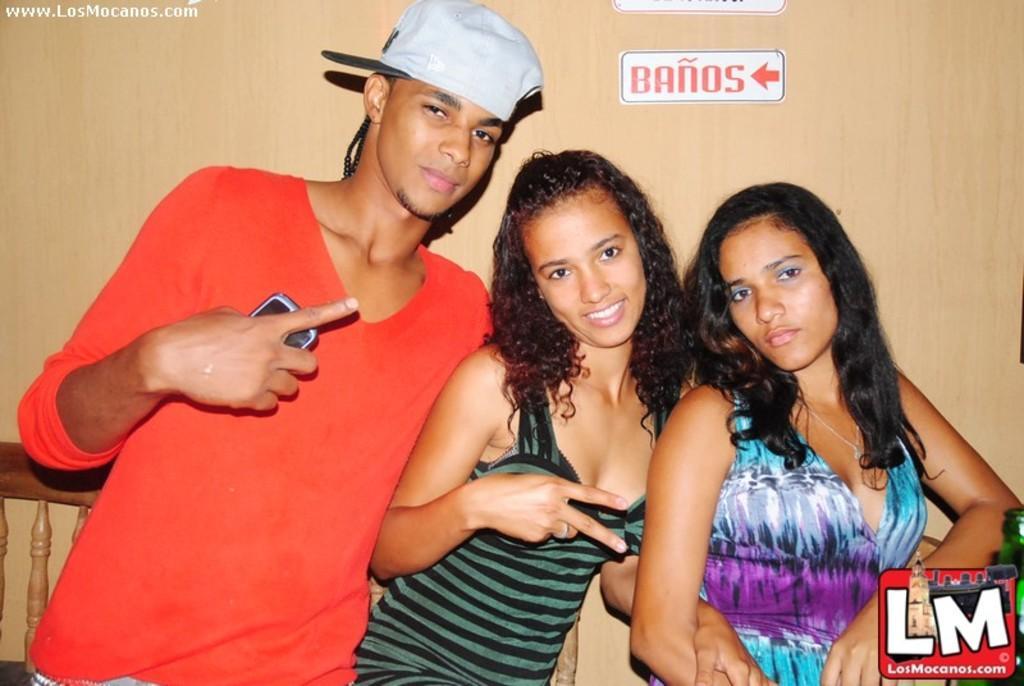Can you describe this image briefly? 3 people are standing. The person at the left is wearing a red t shirt and a cap. Behind them there is a wooden railing and a wall. 